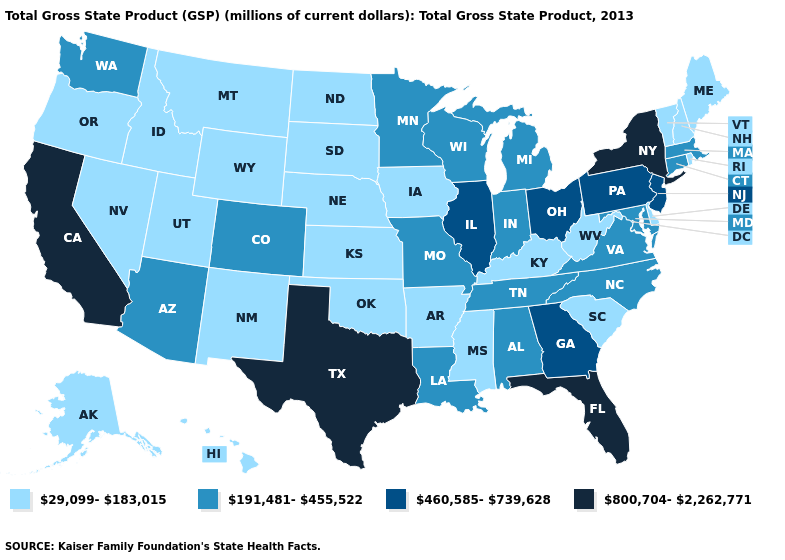Name the states that have a value in the range 191,481-455,522?
Keep it brief. Alabama, Arizona, Colorado, Connecticut, Indiana, Louisiana, Maryland, Massachusetts, Michigan, Minnesota, Missouri, North Carolina, Tennessee, Virginia, Washington, Wisconsin. Which states have the lowest value in the West?
Short answer required. Alaska, Hawaii, Idaho, Montana, Nevada, New Mexico, Oregon, Utah, Wyoming. Name the states that have a value in the range 29,099-183,015?
Answer briefly. Alaska, Arkansas, Delaware, Hawaii, Idaho, Iowa, Kansas, Kentucky, Maine, Mississippi, Montana, Nebraska, Nevada, New Hampshire, New Mexico, North Dakota, Oklahoma, Oregon, Rhode Island, South Carolina, South Dakota, Utah, Vermont, West Virginia, Wyoming. Name the states that have a value in the range 29,099-183,015?
Quick response, please. Alaska, Arkansas, Delaware, Hawaii, Idaho, Iowa, Kansas, Kentucky, Maine, Mississippi, Montana, Nebraska, Nevada, New Hampshire, New Mexico, North Dakota, Oklahoma, Oregon, Rhode Island, South Carolina, South Dakota, Utah, Vermont, West Virginia, Wyoming. Name the states that have a value in the range 191,481-455,522?
Give a very brief answer. Alabama, Arizona, Colorado, Connecticut, Indiana, Louisiana, Maryland, Massachusetts, Michigan, Minnesota, Missouri, North Carolina, Tennessee, Virginia, Washington, Wisconsin. Name the states that have a value in the range 29,099-183,015?
Quick response, please. Alaska, Arkansas, Delaware, Hawaii, Idaho, Iowa, Kansas, Kentucky, Maine, Mississippi, Montana, Nebraska, Nevada, New Hampshire, New Mexico, North Dakota, Oklahoma, Oregon, Rhode Island, South Carolina, South Dakota, Utah, Vermont, West Virginia, Wyoming. Among the states that border North Carolina , does Virginia have the lowest value?
Short answer required. No. What is the value of Louisiana?
Give a very brief answer. 191,481-455,522. What is the value of Hawaii?
Keep it brief. 29,099-183,015. What is the value of Arkansas?
Give a very brief answer. 29,099-183,015. Does the map have missing data?
Write a very short answer. No. What is the value of Louisiana?
Quick response, please. 191,481-455,522. Does the first symbol in the legend represent the smallest category?
Write a very short answer. Yes. Does Florida have the highest value in the South?
Quick response, please. Yes. Does Mississippi have the lowest value in the USA?
Be succinct. Yes. 